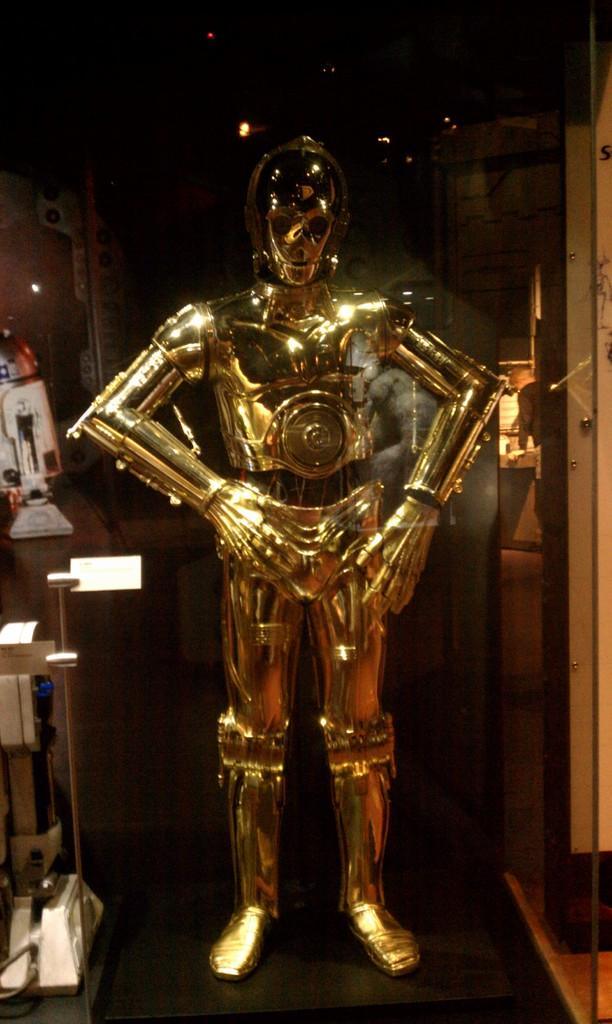What is: What is the main subject of the image? The main subject of the image is a robot on a platform. What material is present in the image? There is glass in the image. Can you describe the other objects in the image? There are other objects in the image, but their specific details are not mentioned in the provided facts. What is the color of the background in the image? The background of the image is dark. What can be seen providing illumination in the image? There is a light visible in the image. What type of ship can be seen sailing in the background of the image? There is no ship visible in the image; the background is dark. What effect does the robot have on the smell in the image? There is no mention of smell in the image, and the robot is not interacting with any objects or substances that would produce a smell. 